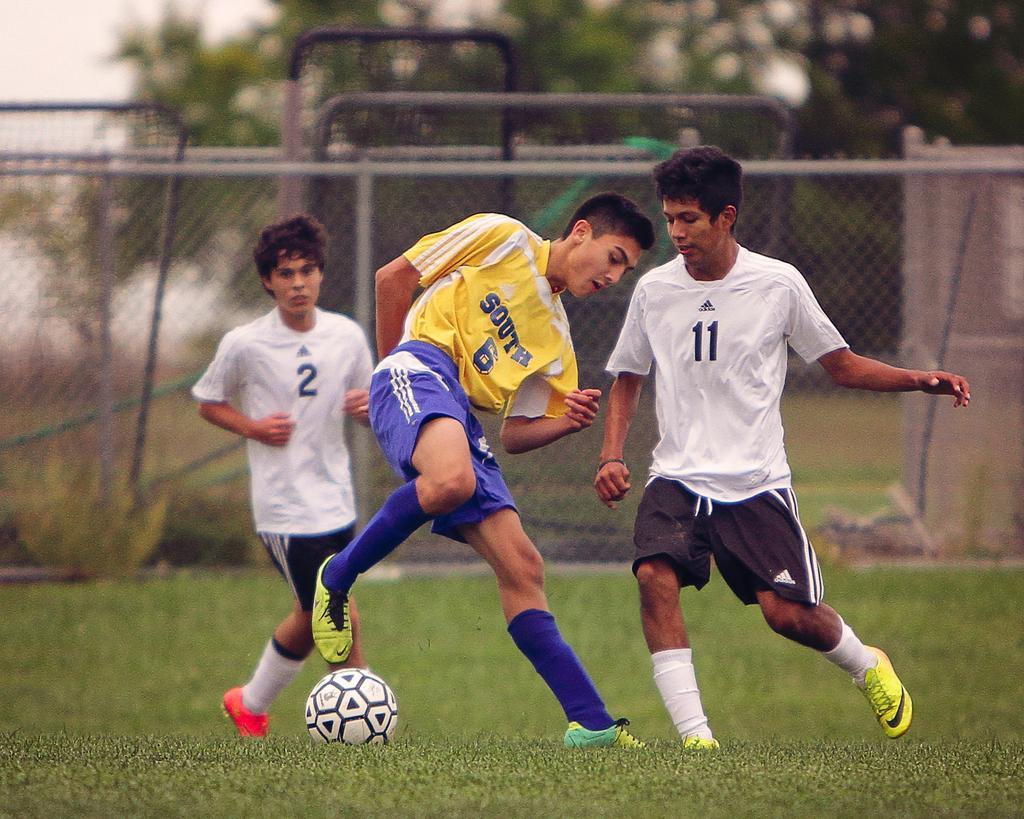Please provide a concise description of this image. There are two people running and this person in motion. We can see ball on the grass. In the background we can see fence,trees and sky. 